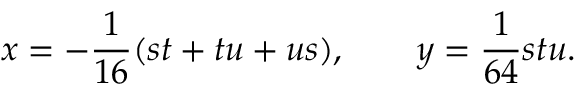<formula> <loc_0><loc_0><loc_500><loc_500>x = - { \frac { 1 } { 1 6 } } ( s t + t u + u s ) , \quad y = { \frac { 1 } { 6 4 } } s t u .</formula> 